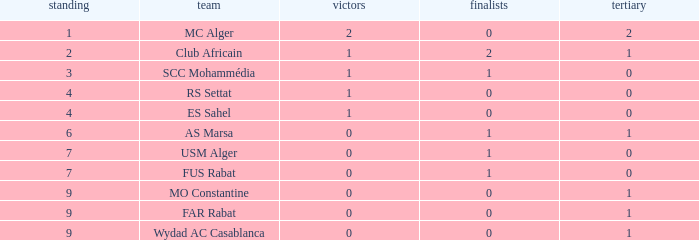Which Third has Runners-up of 0, and Winners of 0, and a Club of far rabat? 1.0. 